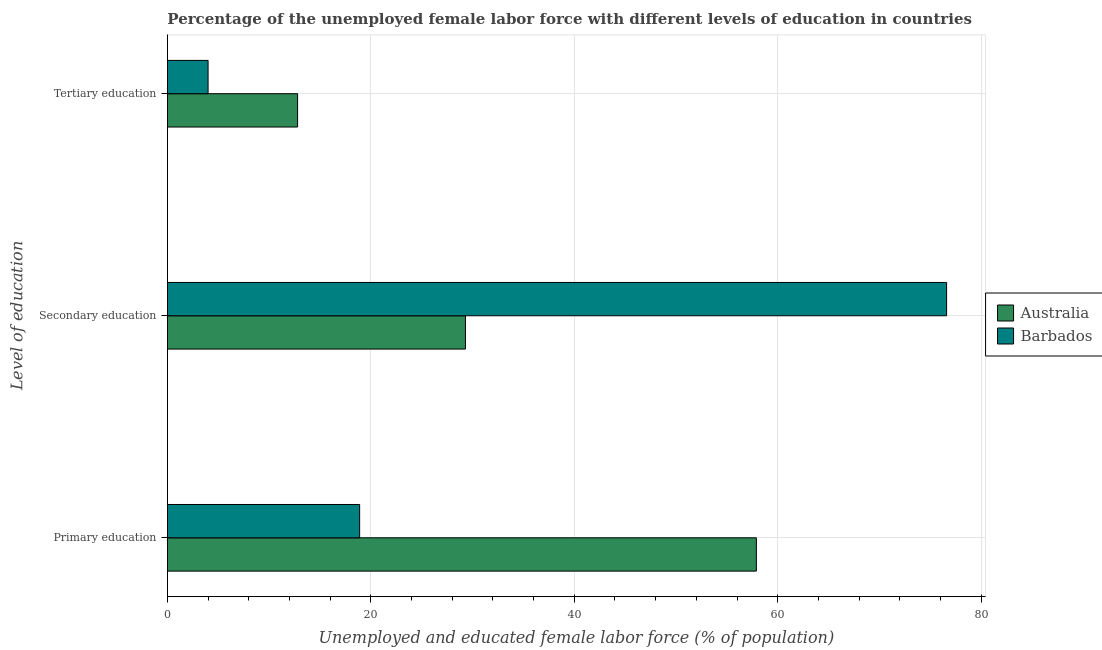How many different coloured bars are there?
Give a very brief answer. 2. How many bars are there on the 2nd tick from the top?
Your answer should be compact. 2. How many bars are there on the 3rd tick from the bottom?
Make the answer very short. 2. What is the label of the 2nd group of bars from the top?
Provide a short and direct response. Secondary education. What is the percentage of female labor force who received secondary education in Australia?
Make the answer very short. 29.3. Across all countries, what is the maximum percentage of female labor force who received tertiary education?
Give a very brief answer. 12.8. Across all countries, what is the minimum percentage of female labor force who received secondary education?
Keep it short and to the point. 29.3. In which country was the percentage of female labor force who received tertiary education maximum?
Your response must be concise. Australia. In which country was the percentage of female labor force who received tertiary education minimum?
Your answer should be compact. Barbados. What is the total percentage of female labor force who received primary education in the graph?
Give a very brief answer. 76.8. What is the difference between the percentage of female labor force who received tertiary education in Barbados and that in Australia?
Offer a very short reply. -8.8. What is the difference between the percentage of female labor force who received secondary education in Australia and the percentage of female labor force who received primary education in Barbados?
Make the answer very short. 10.4. What is the average percentage of female labor force who received primary education per country?
Offer a terse response. 38.4. What is the difference between the percentage of female labor force who received primary education and percentage of female labor force who received tertiary education in Australia?
Your answer should be very brief. 45.1. In how many countries, is the percentage of female labor force who received primary education greater than 28 %?
Your answer should be compact. 1. What is the ratio of the percentage of female labor force who received secondary education in Barbados to that in Australia?
Offer a terse response. 2.61. What is the difference between the highest and the second highest percentage of female labor force who received primary education?
Keep it short and to the point. 39. What is the difference between the highest and the lowest percentage of female labor force who received primary education?
Offer a very short reply. 39. In how many countries, is the percentage of female labor force who received tertiary education greater than the average percentage of female labor force who received tertiary education taken over all countries?
Your answer should be very brief. 1. What does the 2nd bar from the top in Secondary education represents?
Provide a short and direct response. Australia. What does the 1st bar from the bottom in Secondary education represents?
Your response must be concise. Australia. What is the difference between two consecutive major ticks on the X-axis?
Offer a very short reply. 20. Are the values on the major ticks of X-axis written in scientific E-notation?
Your answer should be compact. No. How are the legend labels stacked?
Offer a terse response. Vertical. What is the title of the graph?
Make the answer very short. Percentage of the unemployed female labor force with different levels of education in countries. What is the label or title of the X-axis?
Your answer should be very brief. Unemployed and educated female labor force (% of population). What is the label or title of the Y-axis?
Ensure brevity in your answer.  Level of education. What is the Unemployed and educated female labor force (% of population) of Australia in Primary education?
Offer a terse response. 57.9. What is the Unemployed and educated female labor force (% of population) in Barbados in Primary education?
Your response must be concise. 18.9. What is the Unemployed and educated female labor force (% of population) in Australia in Secondary education?
Offer a very short reply. 29.3. What is the Unemployed and educated female labor force (% of population) of Barbados in Secondary education?
Ensure brevity in your answer.  76.6. What is the Unemployed and educated female labor force (% of population) of Australia in Tertiary education?
Provide a short and direct response. 12.8. What is the Unemployed and educated female labor force (% of population) in Barbados in Tertiary education?
Your answer should be compact. 4. Across all Level of education, what is the maximum Unemployed and educated female labor force (% of population) in Australia?
Provide a short and direct response. 57.9. Across all Level of education, what is the maximum Unemployed and educated female labor force (% of population) of Barbados?
Provide a short and direct response. 76.6. Across all Level of education, what is the minimum Unemployed and educated female labor force (% of population) of Australia?
Your answer should be compact. 12.8. What is the total Unemployed and educated female labor force (% of population) of Australia in the graph?
Your response must be concise. 100. What is the total Unemployed and educated female labor force (% of population) of Barbados in the graph?
Provide a short and direct response. 99.5. What is the difference between the Unemployed and educated female labor force (% of population) of Australia in Primary education and that in Secondary education?
Offer a very short reply. 28.6. What is the difference between the Unemployed and educated female labor force (% of population) of Barbados in Primary education and that in Secondary education?
Ensure brevity in your answer.  -57.7. What is the difference between the Unemployed and educated female labor force (% of population) of Australia in Primary education and that in Tertiary education?
Keep it short and to the point. 45.1. What is the difference between the Unemployed and educated female labor force (% of population) in Australia in Secondary education and that in Tertiary education?
Offer a very short reply. 16.5. What is the difference between the Unemployed and educated female labor force (% of population) of Barbados in Secondary education and that in Tertiary education?
Provide a short and direct response. 72.6. What is the difference between the Unemployed and educated female labor force (% of population) of Australia in Primary education and the Unemployed and educated female labor force (% of population) of Barbados in Secondary education?
Give a very brief answer. -18.7. What is the difference between the Unemployed and educated female labor force (% of population) of Australia in Primary education and the Unemployed and educated female labor force (% of population) of Barbados in Tertiary education?
Your answer should be very brief. 53.9. What is the difference between the Unemployed and educated female labor force (% of population) in Australia in Secondary education and the Unemployed and educated female labor force (% of population) in Barbados in Tertiary education?
Provide a short and direct response. 25.3. What is the average Unemployed and educated female labor force (% of population) in Australia per Level of education?
Offer a terse response. 33.33. What is the average Unemployed and educated female labor force (% of population) of Barbados per Level of education?
Your answer should be compact. 33.17. What is the difference between the Unemployed and educated female labor force (% of population) in Australia and Unemployed and educated female labor force (% of population) in Barbados in Primary education?
Your response must be concise. 39. What is the difference between the Unemployed and educated female labor force (% of population) of Australia and Unemployed and educated female labor force (% of population) of Barbados in Secondary education?
Provide a succinct answer. -47.3. What is the ratio of the Unemployed and educated female labor force (% of population) of Australia in Primary education to that in Secondary education?
Keep it short and to the point. 1.98. What is the ratio of the Unemployed and educated female labor force (% of population) in Barbados in Primary education to that in Secondary education?
Your answer should be compact. 0.25. What is the ratio of the Unemployed and educated female labor force (% of population) in Australia in Primary education to that in Tertiary education?
Your response must be concise. 4.52. What is the ratio of the Unemployed and educated female labor force (% of population) in Barbados in Primary education to that in Tertiary education?
Provide a short and direct response. 4.72. What is the ratio of the Unemployed and educated female labor force (% of population) of Australia in Secondary education to that in Tertiary education?
Make the answer very short. 2.29. What is the ratio of the Unemployed and educated female labor force (% of population) in Barbados in Secondary education to that in Tertiary education?
Your answer should be compact. 19.15. What is the difference between the highest and the second highest Unemployed and educated female labor force (% of population) of Australia?
Offer a very short reply. 28.6. What is the difference between the highest and the second highest Unemployed and educated female labor force (% of population) of Barbados?
Offer a very short reply. 57.7. What is the difference between the highest and the lowest Unemployed and educated female labor force (% of population) of Australia?
Make the answer very short. 45.1. What is the difference between the highest and the lowest Unemployed and educated female labor force (% of population) in Barbados?
Offer a terse response. 72.6. 